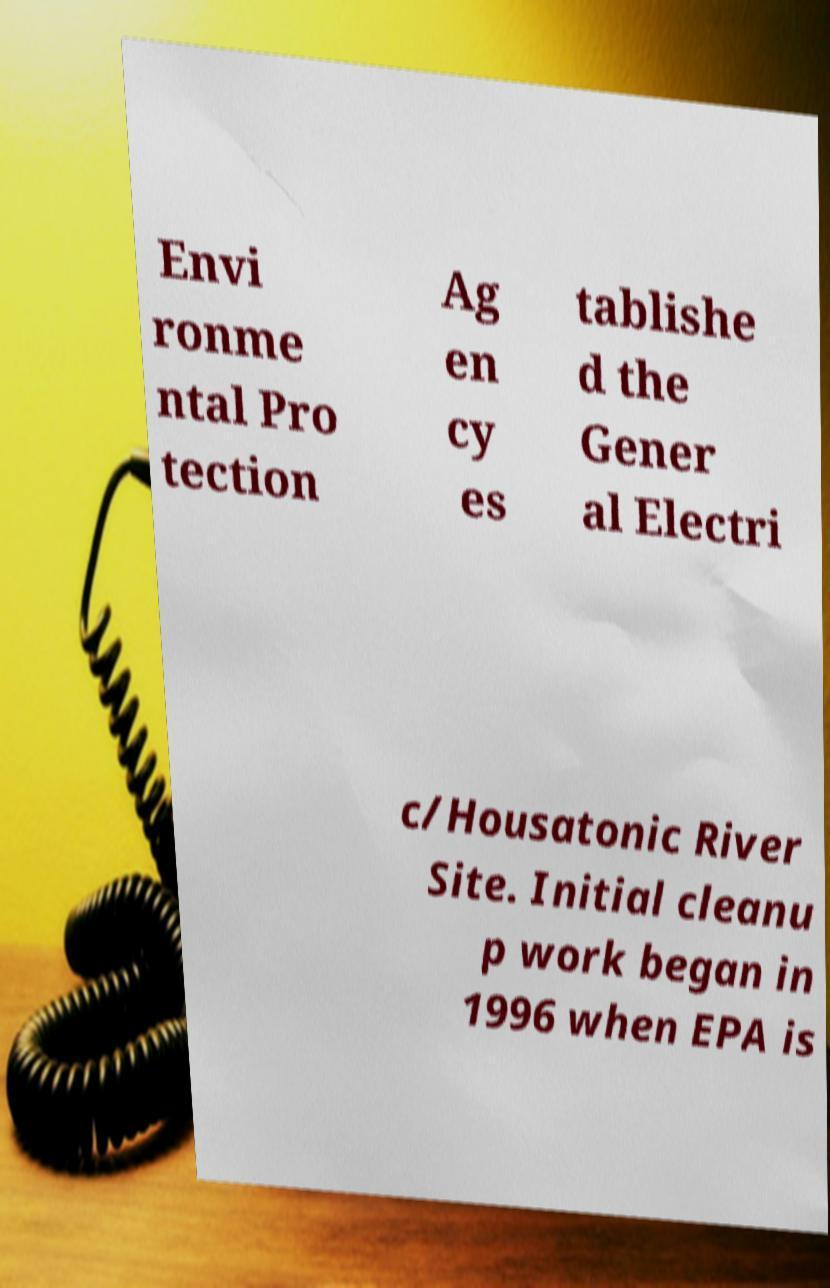Could you extract and type out the text from this image? Envi ronme ntal Pro tection Ag en cy es tablishe d the Gener al Electri c/Housatonic River Site. Initial cleanu p work began in 1996 when EPA is 